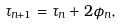<formula> <loc_0><loc_0><loc_500><loc_500>\tau _ { n + 1 } = \tau _ { n } + 2 \phi _ { n } ,</formula> 